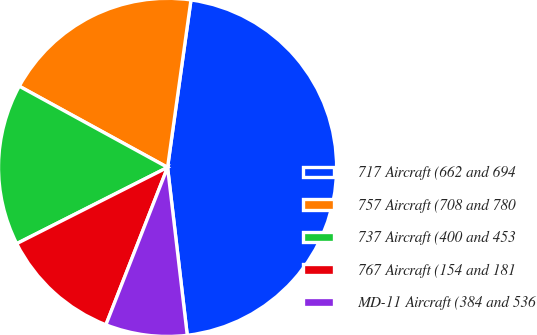<chart> <loc_0><loc_0><loc_500><loc_500><pie_chart><fcel>717 Aircraft (662 and 694<fcel>757 Aircraft (708 and 780<fcel>737 Aircraft (400 and 453<fcel>767 Aircraft (154 and 181<fcel>MD-11 Aircraft (384 and 536<nl><fcel>45.93%<fcel>19.24%<fcel>15.42%<fcel>11.61%<fcel>7.8%<nl></chart> 